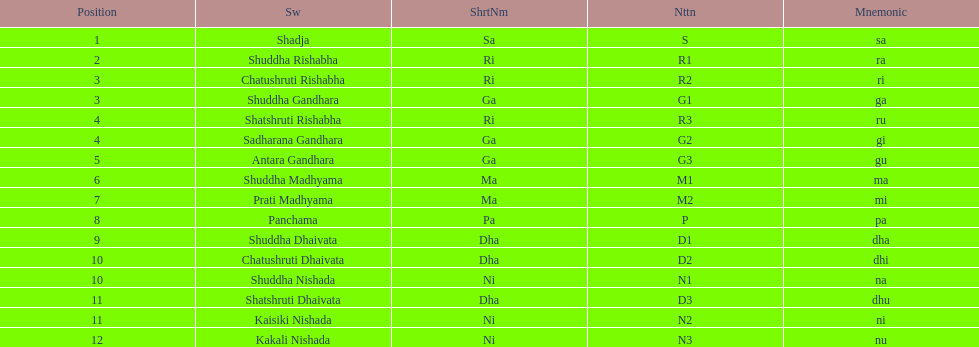Which swara holds the last position? Kakali Nishada. 